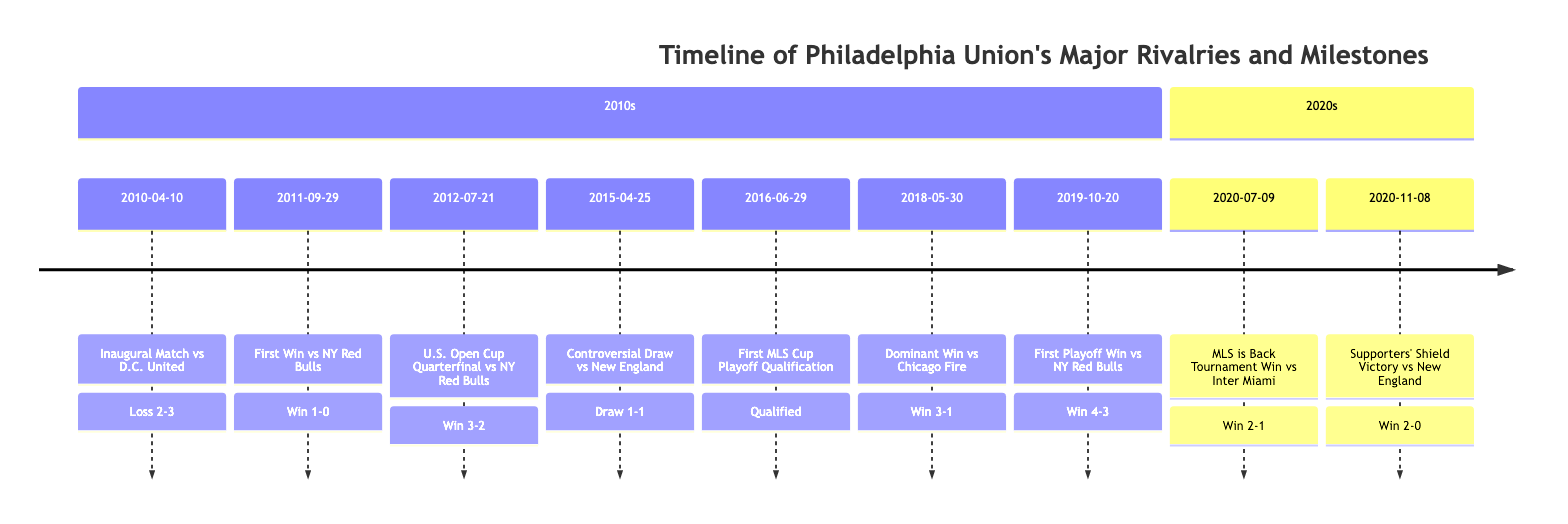What was the date of the inaugural match against D.C. United? The inaugural match against D.C. United is recorded in the timeline with the date listed as April 10, 2010.
Answer: April 10, 2010 What was the result of the first win against New York Red Bulls? The timeline specifies that the first win against New York Red Bulls occurred with a score of 1-0, indicating a victory for the Union.
Answer: Win 1-0 How many total matches against New York Red Bulls are mentioned in the timeline? Reviewing the timeline, there are three matches specifically noted against New York Red Bulls: the first win, the U.S. Open Cup Quarterfinal victory, and the first playoff win, which totals three matches.
Answer: 3 What notable moment occurred on June 29, 2016? The timeline indicates that on June 29, 2016, the Philadelphia Union qualified for the playoffs for the first time, marking a significant milestone in the club's history.
Answer: Qualified Which event marked the first playoff win for the Union? The first playoff win for the Union is mentioned as the match on October 20, 2019, where they faced the New York Red Bulls and won in extra time with a score of 4-3.
Answer: Win 4-3 What was the common result of matches against New England Revolution listed in the timeline? There are two matches against New England Revolution mentioned: one is a draw (1-1) from a controversial offside decision, and the other is a victory (2-0) when they clinched the Supporters' Shield. The draw is the notable common result.
Answer: Draw 1-1 How did the Union perform against Chicago Fire on May 30, 2018? The timeline records a dominant victory over Chicago Fire with a score of 3-1, showcasing the Union's strong performance on that date.
Answer: Win 3-1 In which year did the Union clinch their first Supporters' Shield? The timeline indicates that the Union clinched their first Supporters' Shield on November 8, 2020, following a victory against New England Revolution.
Answer: 2020 What significant incident happened on April 25, 2015, involving the Union and New England Revolution? The incident mentioned in the timeline for April 25, 2015, is a controversial offside decision that disallowed a Union goal, leading to a 1-1 draw, which heightened tensions with the Revolution.
Answer: Draw 1-1 